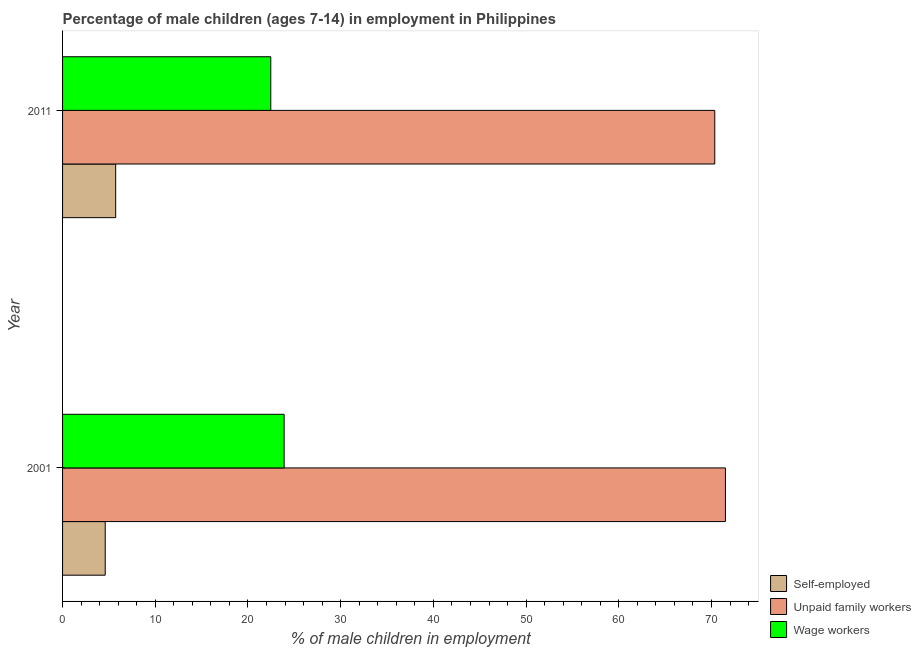How many different coloured bars are there?
Offer a terse response. 3. Are the number of bars per tick equal to the number of legend labels?
Ensure brevity in your answer.  Yes. What is the label of the 1st group of bars from the top?
Your answer should be very brief. 2011. What is the percentage of children employed as unpaid family workers in 2011?
Your answer should be very brief. 70.35. Across all years, what is the maximum percentage of children employed as unpaid family workers?
Offer a very short reply. 71.5. Across all years, what is the minimum percentage of children employed as unpaid family workers?
Ensure brevity in your answer.  70.35. In which year was the percentage of children employed as unpaid family workers maximum?
Your answer should be very brief. 2001. In which year was the percentage of children employed as unpaid family workers minimum?
Keep it short and to the point. 2011. What is the total percentage of self employed children in the graph?
Offer a very short reply. 10.33. What is the difference between the percentage of self employed children in 2001 and that in 2011?
Keep it short and to the point. -1.13. What is the difference between the percentage of self employed children in 2001 and the percentage of children employed as wage workers in 2011?
Provide a short and direct response. -17.86. What is the average percentage of children employed as unpaid family workers per year?
Your answer should be very brief. 70.92. In the year 2001, what is the difference between the percentage of self employed children and percentage of children employed as wage workers?
Provide a short and direct response. -19.3. What is the ratio of the percentage of self employed children in 2001 to that in 2011?
Keep it short and to the point. 0.8. In how many years, is the percentage of self employed children greater than the average percentage of self employed children taken over all years?
Keep it short and to the point. 1. What does the 2nd bar from the top in 2011 represents?
Provide a succinct answer. Unpaid family workers. What does the 2nd bar from the bottom in 2001 represents?
Provide a succinct answer. Unpaid family workers. Is it the case that in every year, the sum of the percentage of self employed children and percentage of children employed as unpaid family workers is greater than the percentage of children employed as wage workers?
Provide a short and direct response. Yes. How many bars are there?
Give a very brief answer. 6. How many years are there in the graph?
Provide a short and direct response. 2. What is the difference between two consecutive major ticks on the X-axis?
Keep it short and to the point. 10. Does the graph contain any zero values?
Your answer should be very brief. No. Where does the legend appear in the graph?
Offer a very short reply. Bottom right. How many legend labels are there?
Keep it short and to the point. 3. How are the legend labels stacked?
Offer a terse response. Vertical. What is the title of the graph?
Offer a very short reply. Percentage of male children (ages 7-14) in employment in Philippines. Does "Labor Tax" appear as one of the legend labels in the graph?
Your response must be concise. No. What is the label or title of the X-axis?
Keep it short and to the point. % of male children in employment. What is the label or title of the Y-axis?
Your answer should be very brief. Year. What is the % of male children in employment in Unpaid family workers in 2001?
Offer a very short reply. 71.5. What is the % of male children in employment of Wage workers in 2001?
Your response must be concise. 23.9. What is the % of male children in employment in Self-employed in 2011?
Ensure brevity in your answer.  5.73. What is the % of male children in employment of Unpaid family workers in 2011?
Give a very brief answer. 70.35. What is the % of male children in employment of Wage workers in 2011?
Make the answer very short. 22.46. Across all years, what is the maximum % of male children in employment of Self-employed?
Ensure brevity in your answer.  5.73. Across all years, what is the maximum % of male children in employment in Unpaid family workers?
Offer a terse response. 71.5. Across all years, what is the maximum % of male children in employment in Wage workers?
Give a very brief answer. 23.9. Across all years, what is the minimum % of male children in employment of Self-employed?
Ensure brevity in your answer.  4.6. Across all years, what is the minimum % of male children in employment in Unpaid family workers?
Offer a terse response. 70.35. Across all years, what is the minimum % of male children in employment in Wage workers?
Make the answer very short. 22.46. What is the total % of male children in employment of Self-employed in the graph?
Your answer should be very brief. 10.33. What is the total % of male children in employment of Unpaid family workers in the graph?
Give a very brief answer. 141.85. What is the total % of male children in employment in Wage workers in the graph?
Your answer should be very brief. 46.36. What is the difference between the % of male children in employment of Self-employed in 2001 and that in 2011?
Provide a short and direct response. -1.13. What is the difference between the % of male children in employment of Unpaid family workers in 2001 and that in 2011?
Keep it short and to the point. 1.15. What is the difference between the % of male children in employment of Wage workers in 2001 and that in 2011?
Make the answer very short. 1.44. What is the difference between the % of male children in employment in Self-employed in 2001 and the % of male children in employment in Unpaid family workers in 2011?
Offer a terse response. -65.75. What is the difference between the % of male children in employment of Self-employed in 2001 and the % of male children in employment of Wage workers in 2011?
Keep it short and to the point. -17.86. What is the difference between the % of male children in employment in Unpaid family workers in 2001 and the % of male children in employment in Wage workers in 2011?
Your answer should be very brief. 49.04. What is the average % of male children in employment in Self-employed per year?
Give a very brief answer. 5.17. What is the average % of male children in employment in Unpaid family workers per year?
Make the answer very short. 70.92. What is the average % of male children in employment of Wage workers per year?
Make the answer very short. 23.18. In the year 2001, what is the difference between the % of male children in employment in Self-employed and % of male children in employment in Unpaid family workers?
Your answer should be very brief. -66.9. In the year 2001, what is the difference between the % of male children in employment of Self-employed and % of male children in employment of Wage workers?
Ensure brevity in your answer.  -19.3. In the year 2001, what is the difference between the % of male children in employment in Unpaid family workers and % of male children in employment in Wage workers?
Ensure brevity in your answer.  47.6. In the year 2011, what is the difference between the % of male children in employment of Self-employed and % of male children in employment of Unpaid family workers?
Provide a succinct answer. -64.62. In the year 2011, what is the difference between the % of male children in employment of Self-employed and % of male children in employment of Wage workers?
Ensure brevity in your answer.  -16.73. In the year 2011, what is the difference between the % of male children in employment of Unpaid family workers and % of male children in employment of Wage workers?
Ensure brevity in your answer.  47.89. What is the ratio of the % of male children in employment in Self-employed in 2001 to that in 2011?
Provide a short and direct response. 0.8. What is the ratio of the % of male children in employment of Unpaid family workers in 2001 to that in 2011?
Provide a succinct answer. 1.02. What is the ratio of the % of male children in employment of Wage workers in 2001 to that in 2011?
Give a very brief answer. 1.06. What is the difference between the highest and the second highest % of male children in employment of Self-employed?
Offer a terse response. 1.13. What is the difference between the highest and the second highest % of male children in employment of Unpaid family workers?
Keep it short and to the point. 1.15. What is the difference between the highest and the second highest % of male children in employment of Wage workers?
Make the answer very short. 1.44. What is the difference between the highest and the lowest % of male children in employment of Self-employed?
Offer a very short reply. 1.13. What is the difference between the highest and the lowest % of male children in employment in Unpaid family workers?
Offer a very short reply. 1.15. What is the difference between the highest and the lowest % of male children in employment in Wage workers?
Your answer should be compact. 1.44. 